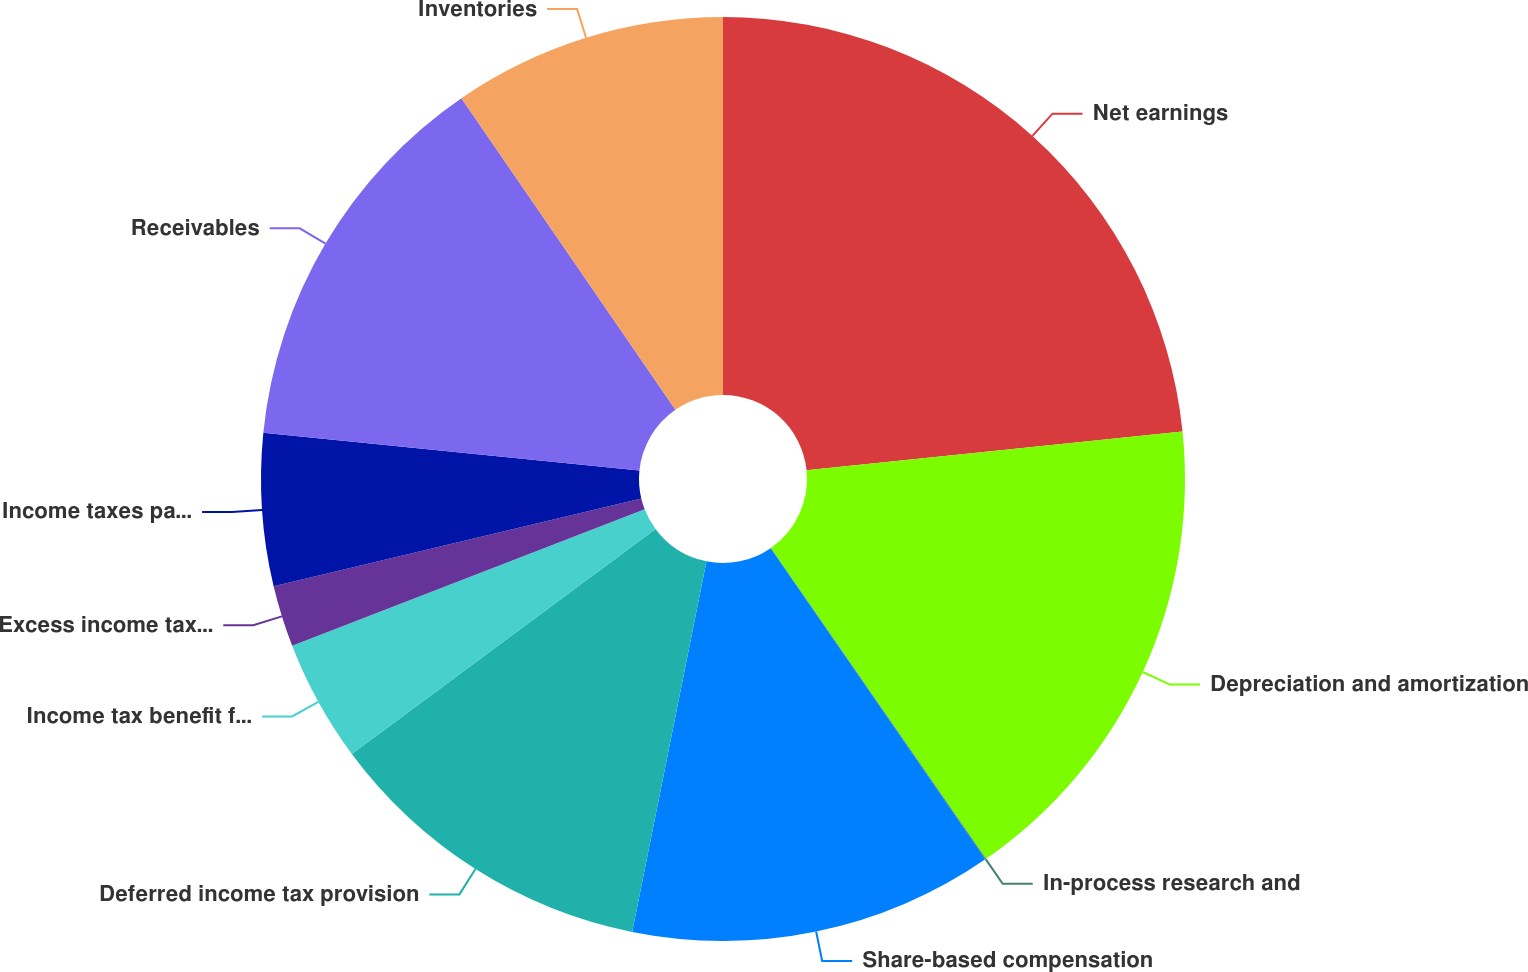<chart> <loc_0><loc_0><loc_500><loc_500><pie_chart><fcel>Net earnings<fcel>Depreciation and amortization<fcel>In-process research and<fcel>Share-based compensation<fcel>Deferred income tax provision<fcel>Income tax benefit from stock<fcel>Excess income tax benefit from<fcel>Income taxes payable<fcel>Receivables<fcel>Inventories<nl><fcel>23.36%<fcel>17.0%<fcel>0.03%<fcel>12.76%<fcel>11.7%<fcel>4.27%<fcel>2.15%<fcel>5.33%<fcel>13.82%<fcel>9.58%<nl></chart> 